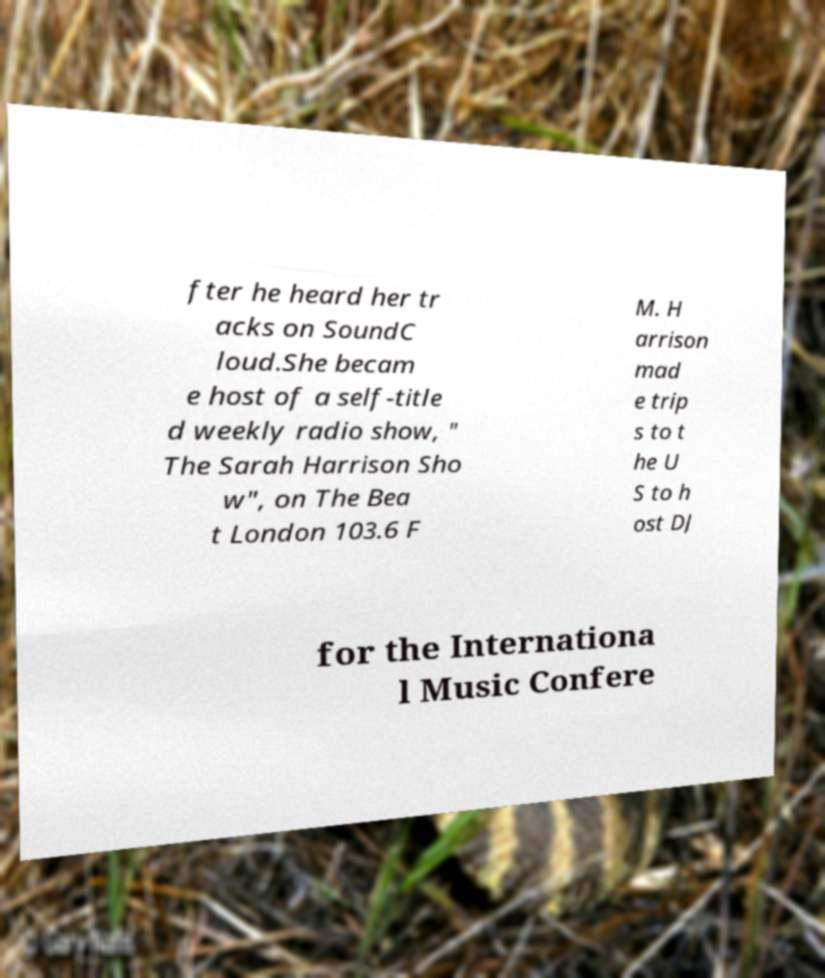Could you extract and type out the text from this image? fter he heard her tr acks on SoundC loud.She becam e host of a self-title d weekly radio show, " The Sarah Harrison Sho w", on The Bea t London 103.6 F M. H arrison mad e trip s to t he U S to h ost DJ for the Internationa l Music Confere 